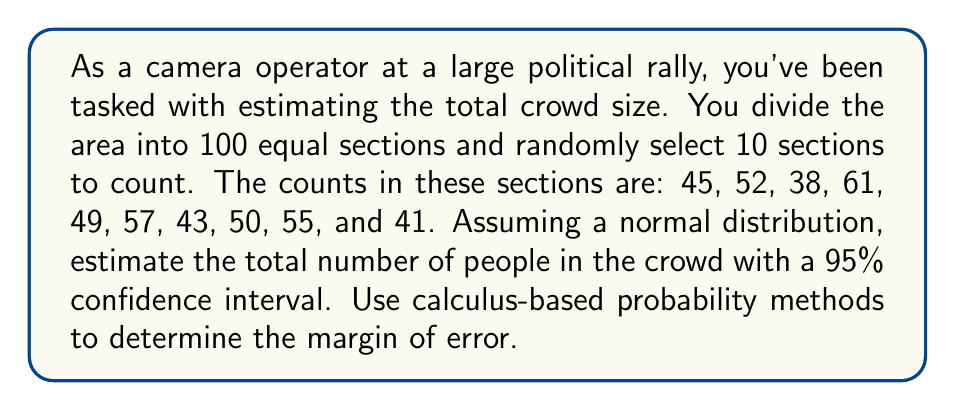Help me with this question. To solve this problem, we'll use statistical sampling and calculus-based probability methods. Let's break it down step-by-step:

1. Calculate the sample mean ($\bar{x}$):
   $$\bar{x} = \frac{45 + 52 + 38 + 61 + 49 + 57 + 43 + 50 + 55 + 41}{10} = 49.1$$

2. Calculate the sample standard deviation ($s$):
   $$s = \sqrt{\frac{\sum_{i=1}^{n} (x_i - \bar{x})^2}{n-1}}$$
   $$s \approx 7.0362$$

3. For a 95% confidence interval, we use a z-score of 1.96 (from the standard normal distribution).

4. The margin of error (ME) for the mean of each section is:
   $$ME = z \cdot \frac{s}{\sqrt{n}} = 1.96 \cdot \frac{7.0362}{\sqrt{10}} \approx 4.3584$$

5. The confidence interval for the mean of each section is:
   $$(\bar{x} - ME, \bar{x} + ME) = (44.7416, 53.4584)$$

6. To estimate the total crowd size, we multiply by the total number of sections:
   Lower bound: $44.7416 \cdot 100 = 4,474.16$
   Upper bound: $53.4584 \cdot 100 = 5,345.84$

7. The margin of error for the total crowd size is:
   $$ME_{total} = ME \cdot 100 = 4.3584 \cdot 100 = 435.84$$

8. Using calculus-based probability, we can derive the probability density function (PDF) of the normal distribution:
   $$f(x) = \frac{1}{\sigma\sqrt{2\pi}} e^{-\frac{(x-\mu)^2}{2\sigma^2}}$$

9. The area under this curve between $\mu - 1.96\sigma$ and $\mu + 1.96\sigma$ gives us the 95% confidence interval:
   $$P(\mu - 1.96\sigma < X < \mu + 1.96\sigma) = \int_{\mu - 1.96\sigma}^{\mu + 1.96\sigma} \frac{1}{\sigma\sqrt{2\pi}} e^{-\frac{(x-\mu)^2}{2\sigma^2}} dx = 0.95$$

This integral represents the probability that the true population mean falls within our calculated confidence interval.
Answer: The estimated total crowd size is 4,910 people, with a 95% confidence interval of (4,474, 5,346) and a margin of error of ±436 people. 